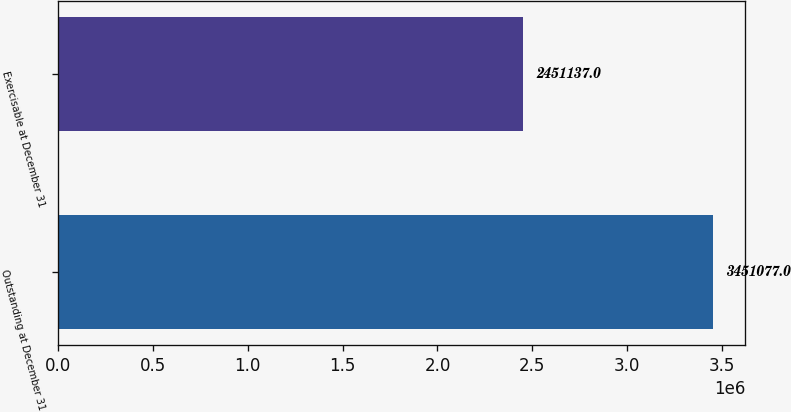Convert chart to OTSL. <chart><loc_0><loc_0><loc_500><loc_500><bar_chart><fcel>Outstanding at December 31<fcel>Exercisable at December 31<nl><fcel>3.45108e+06<fcel>2.45114e+06<nl></chart> 